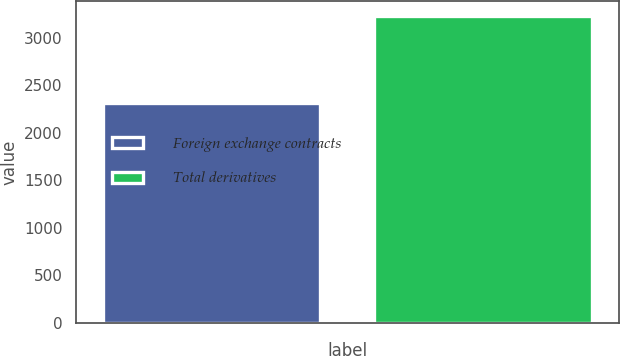<chart> <loc_0><loc_0><loc_500><loc_500><bar_chart><fcel>Foreign exchange contracts<fcel>Total derivatives<nl><fcel>2310<fcel>3224<nl></chart> 